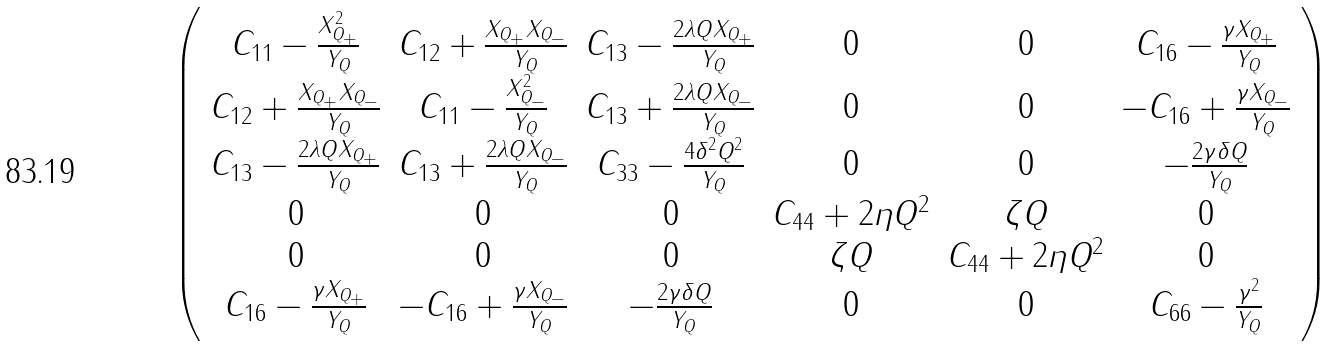<formula> <loc_0><loc_0><loc_500><loc_500>\left ( \begin{array} { c c c c c c } C _ { 1 1 } - \frac { X _ { Q _ { + } } ^ { 2 } } { Y _ { Q } } & C _ { 1 2 } + \frac { X _ { Q _ { + } } X _ { Q _ { - } } } { Y _ { Q } } & C _ { 1 3 } - \frac { 2 \lambda Q X _ { Q _ { + } } } { Y _ { Q } } & 0 & 0 & C _ { 1 6 } - \frac { \gamma X _ { Q _ { + } } } { Y _ { Q } } \\ C _ { 1 2 } + \frac { X _ { Q _ { + } } X _ { Q _ { - } } } { Y _ { Q } } & C _ { 1 1 } - \frac { X _ { Q _ { - } } ^ { 2 } } { Y _ { Q } } & C _ { 1 3 } + \frac { 2 \lambda Q X _ { Q _ { - } } } { Y _ { Q } } & 0 & 0 & - C _ { 1 6 } + \frac { \gamma X _ { Q _ { - } } } { Y _ { Q } } \\ C _ { 1 3 } - \frac { 2 \lambda Q X _ { Q _ { + } } } { Y _ { Q } } & C _ { 1 3 } + \frac { 2 \lambda Q X _ { Q _ { - } } } { Y _ { Q } } & C _ { 3 3 } - \frac { 4 \delta ^ { 2 } Q ^ { 2 } } { Y _ { Q } } & 0 & 0 & - \frac { 2 \gamma \delta Q } { Y _ { Q } } \\ 0 & 0 & 0 & C _ { 4 4 } + 2 \eta Q ^ { 2 } & \zeta Q & 0 \\ 0 & 0 & 0 & \zeta Q & C _ { 4 4 } + 2 \eta Q ^ { 2 } & 0 \\ C _ { 1 6 } - \frac { \gamma X _ { Q _ { + } } } { Y _ { Q } } & - C _ { 1 6 } + \frac { \gamma X _ { Q _ { - } } } { Y _ { Q } } & - \frac { 2 \gamma \delta Q } { Y _ { Q } } & 0 & 0 & C _ { 6 6 } - \frac { \gamma ^ { 2 } } { Y _ { Q } } \\ \end{array} \right )</formula> 